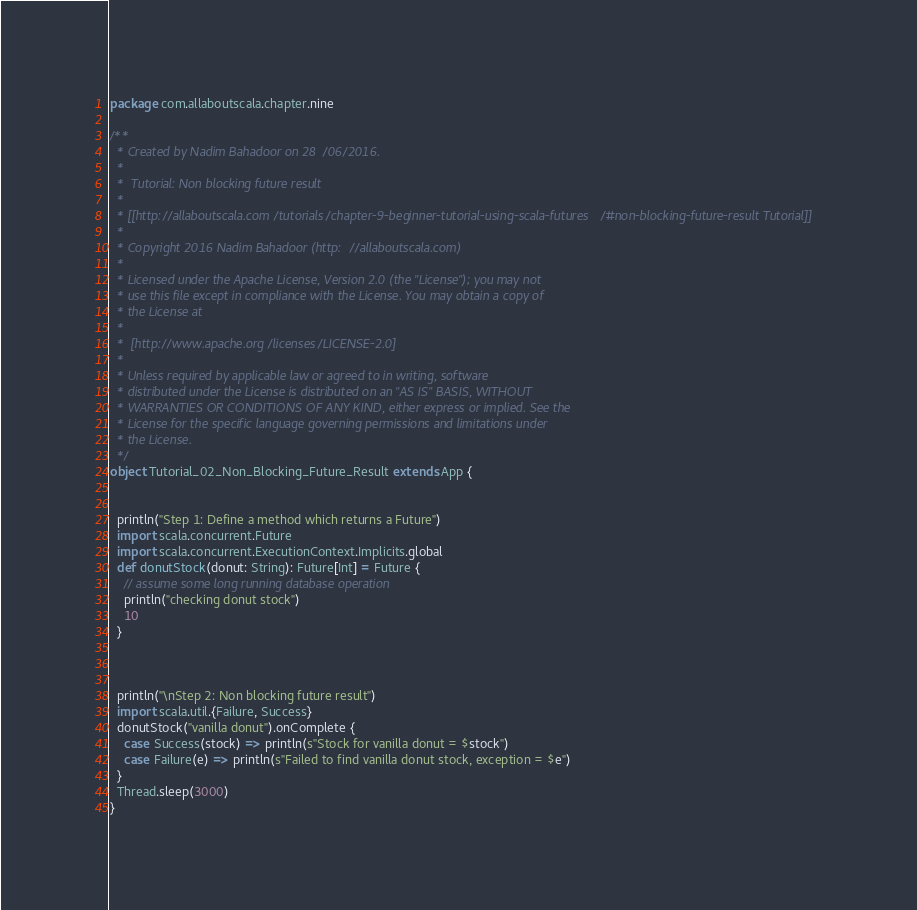<code> <loc_0><loc_0><loc_500><loc_500><_Scala_>package com.allaboutscala.chapter.nine

/**
  * Created by Nadim Bahadoor on 28/06/2016.
  *
  *  Tutorial: Non blocking future result
  *
  * [[http://allaboutscala.com/tutorials/chapter-9-beginner-tutorial-using-scala-futures/#non-blocking-future-result Tutorial]]
  *
  * Copyright 2016 Nadim Bahadoor (http://allaboutscala.com)
  *
  * Licensed under the Apache License, Version 2.0 (the "License"); you may not
  * use this file except in compliance with the License. You may obtain a copy of
  * the License at
  *
  *  [http://www.apache.org/licenses/LICENSE-2.0]
  *
  * Unless required by applicable law or agreed to in writing, software
  * distributed under the License is distributed on an "AS IS" BASIS, WITHOUT
  * WARRANTIES OR CONDITIONS OF ANY KIND, either express or implied. See the
  * License for the specific language governing permissions and limitations under
  * the License.
  */
object Tutorial_02_Non_Blocking_Future_Result extends App {


  println("Step 1: Define a method which returns a Future")
  import scala.concurrent.Future
  import scala.concurrent.ExecutionContext.Implicits.global
  def donutStock(donut: String): Future[Int] = Future {
    // assume some long running database operation
    println("checking donut stock")
    10
  }



  println("\nStep 2: Non blocking future result")
  import scala.util.{Failure, Success}
  donutStock("vanilla donut").onComplete {
    case Success(stock) => println(s"Stock for vanilla donut = $stock")
    case Failure(e) => println(s"Failed to find vanilla donut stock, exception = $e")
  }
  Thread.sleep(3000)
}
</code> 